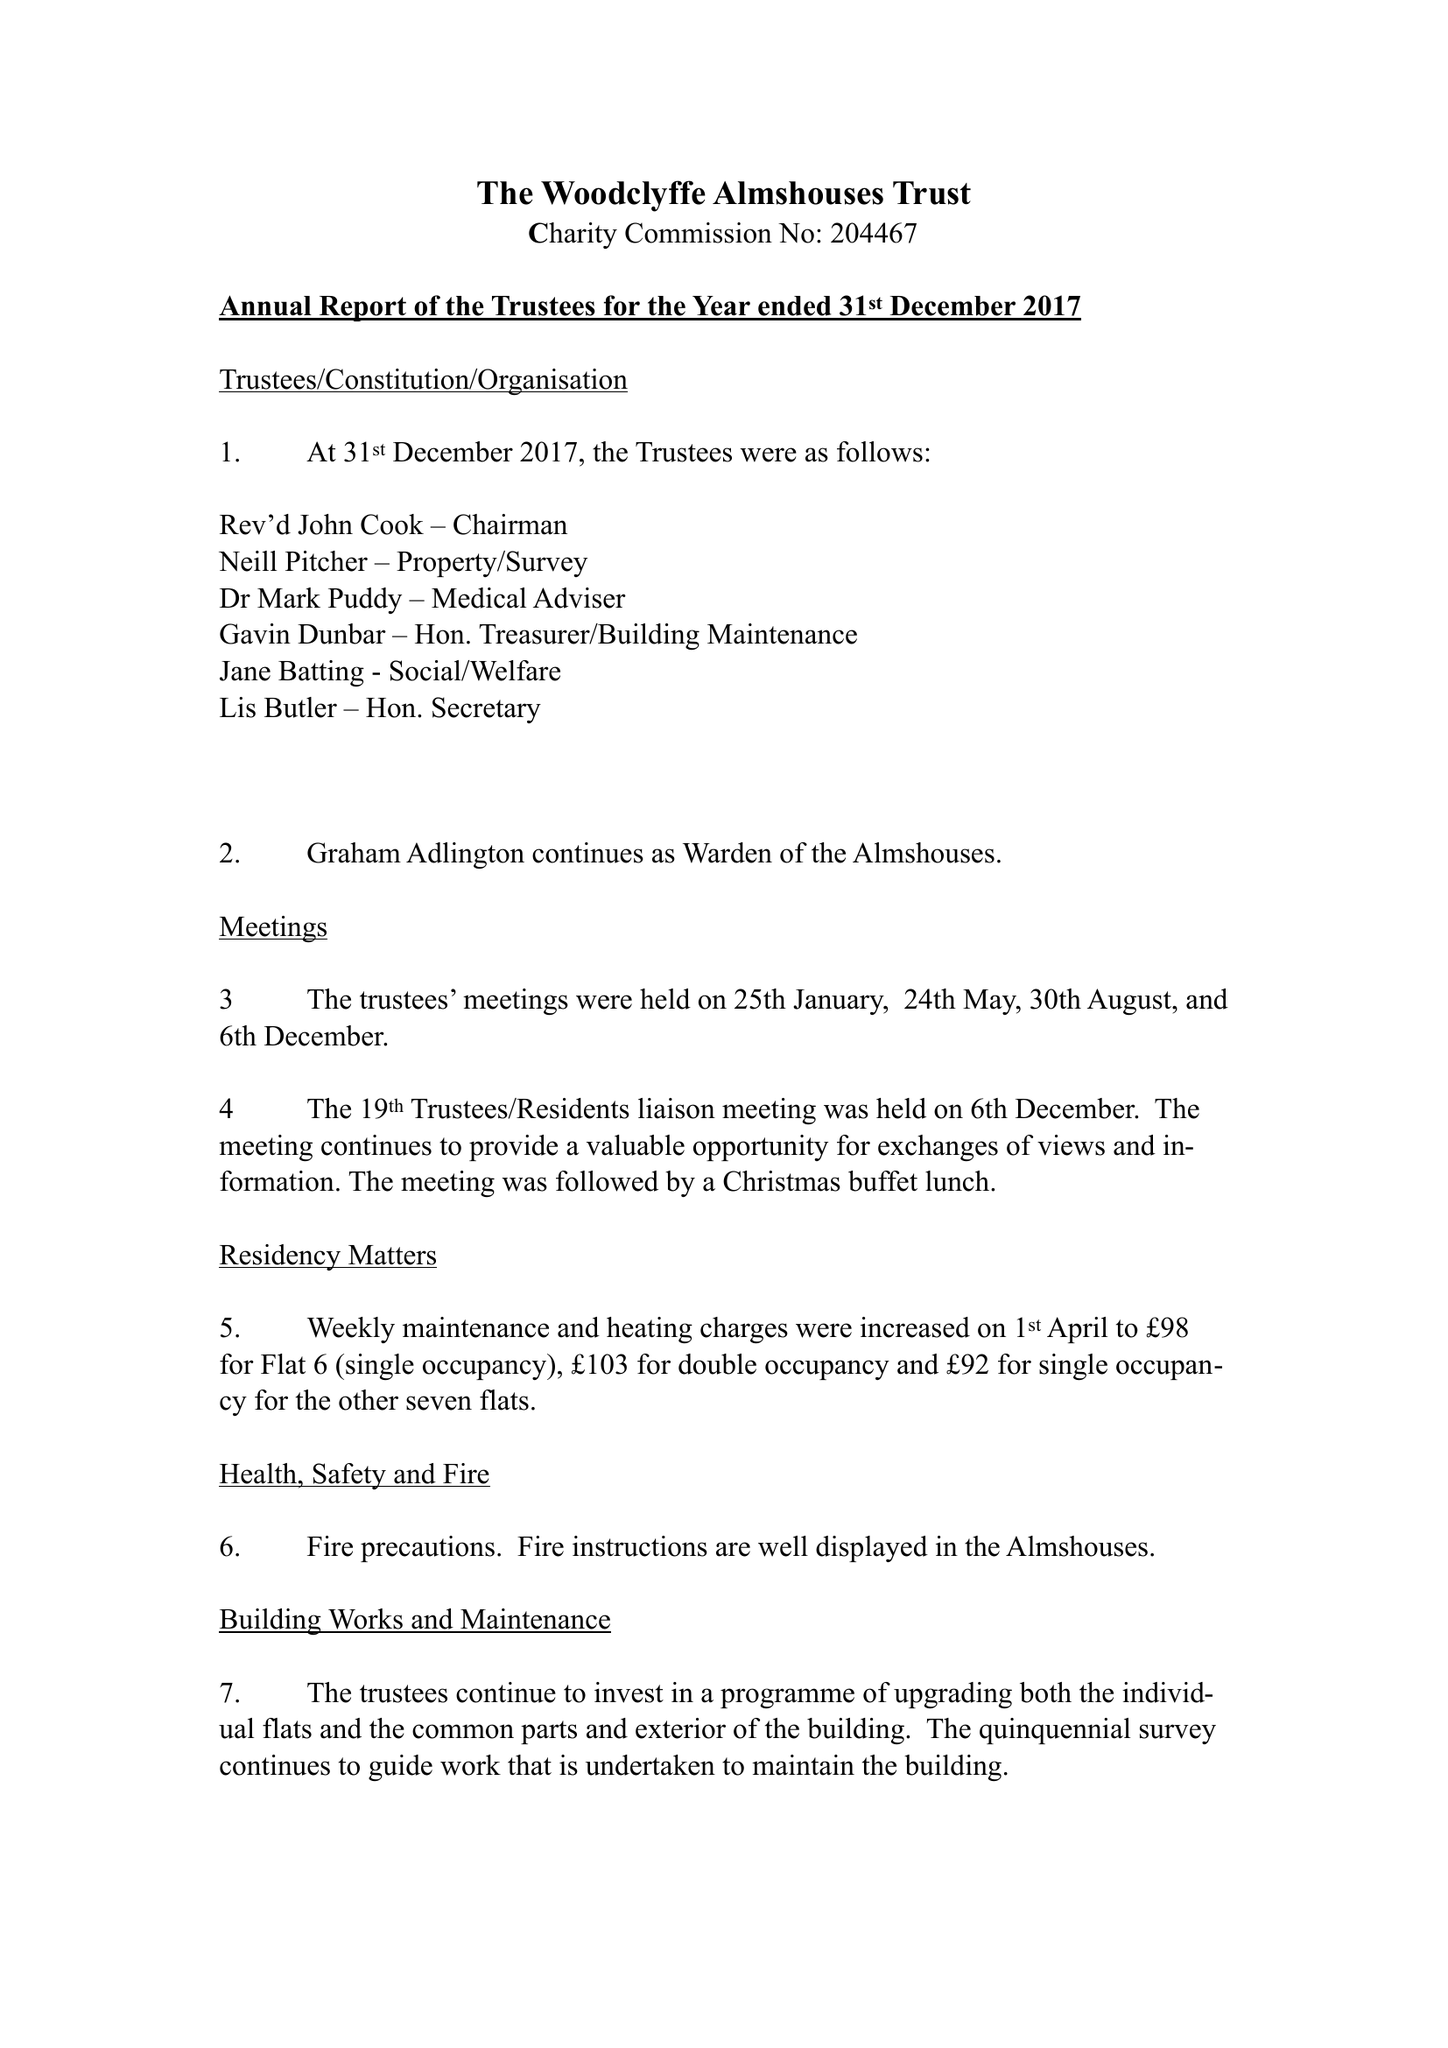What is the value for the income_annually_in_british_pounds?
Answer the question using a single word or phrase. 41902.00 